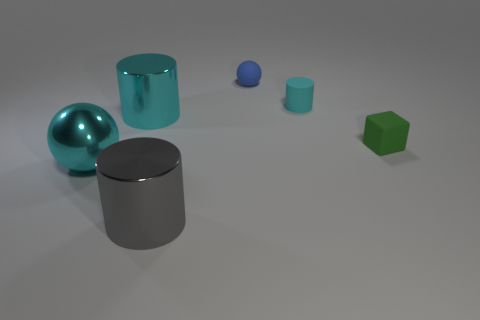The metal thing that is the same color as the big shiny sphere is what size?
Provide a short and direct response. Large. Are there fewer small matte cylinders than big purple cylinders?
Your answer should be very brief. No. Do the large thing in front of the big ball and the large metal sphere have the same color?
Provide a short and direct response. No. The big cylinder left of the metal thing that is right of the cyan shiny thing right of the large ball is made of what material?
Offer a terse response. Metal. Are there any shiny spheres that have the same color as the small rubber ball?
Provide a succinct answer. No. Are there fewer tiny cyan things that are left of the small blue object than blocks?
Make the answer very short. Yes. There is a cyan cylinder in front of the cyan matte cylinder; is it the same size as the tiny cyan matte cylinder?
Offer a very short reply. No. What number of objects are to the left of the small green matte thing and on the right side of the big ball?
Provide a short and direct response. 4. How big is the green block right of the sphere that is behind the large cyan metallic cylinder?
Your answer should be very brief. Small. Is the number of tiny objects that are on the left side of the tiny green matte object less than the number of tiny cyan rubber cylinders behind the tiny cyan rubber object?
Offer a very short reply. No. 